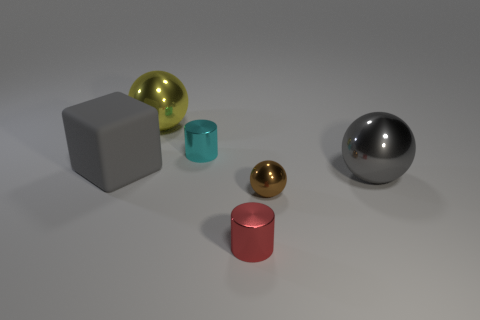Subtract all big gray spheres. How many spheres are left? 2 Add 4 small green matte things. How many objects exist? 10 Subtract all brown spheres. How many spheres are left? 2 Subtract all cylinders. How many objects are left? 4 Subtract 1 blocks. How many blocks are left? 0 Add 6 brown balls. How many brown balls exist? 7 Subtract 1 yellow spheres. How many objects are left? 5 Subtract all yellow cylinders. Subtract all green blocks. How many cylinders are left? 2 Subtract all cyan shiny objects. Subtract all brown metal balls. How many objects are left? 4 Add 6 brown objects. How many brown objects are left? 7 